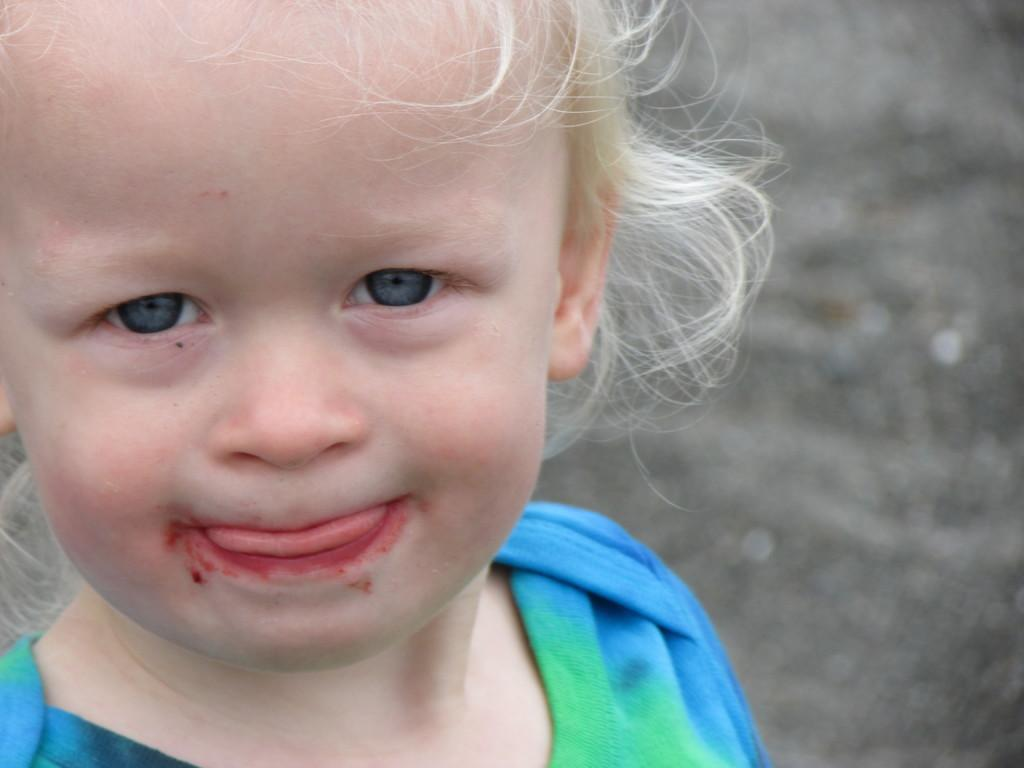What is the main subject of the image? The main subject of the image is a child. Can you describe the child's clothing in the image? The child is wearing a dress with blue and green colors. How would you describe the background of the image? The background of the image is blurred. Can you see any smashed crackers on the seashore in the image? There is no reference to smashed crackers or a seashore in the image, so it's not possible to answer that question. 